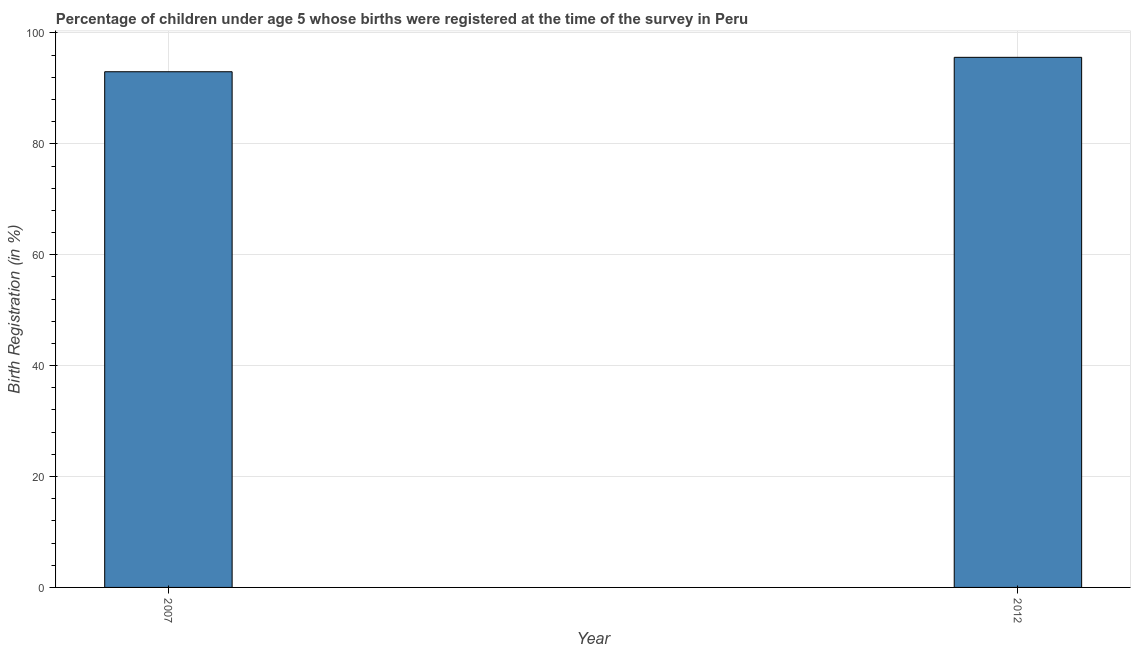What is the title of the graph?
Offer a terse response. Percentage of children under age 5 whose births were registered at the time of the survey in Peru. What is the label or title of the X-axis?
Ensure brevity in your answer.  Year. What is the label or title of the Y-axis?
Your response must be concise. Birth Registration (in %). What is the birth registration in 2012?
Your answer should be very brief. 95.6. Across all years, what is the maximum birth registration?
Provide a short and direct response. 95.6. Across all years, what is the minimum birth registration?
Keep it short and to the point. 93. In which year was the birth registration maximum?
Offer a terse response. 2012. What is the sum of the birth registration?
Your answer should be very brief. 188.6. What is the difference between the birth registration in 2007 and 2012?
Provide a succinct answer. -2.6. What is the average birth registration per year?
Your answer should be very brief. 94.3. What is the median birth registration?
Provide a short and direct response. 94.3. In how many years, is the birth registration greater than 48 %?
Provide a succinct answer. 2. Do a majority of the years between 2007 and 2012 (inclusive) have birth registration greater than 44 %?
Offer a very short reply. Yes. What is the ratio of the birth registration in 2007 to that in 2012?
Offer a terse response. 0.97. Is the birth registration in 2007 less than that in 2012?
Your answer should be compact. Yes. How many bars are there?
Provide a succinct answer. 2. How many years are there in the graph?
Your answer should be very brief. 2. What is the difference between two consecutive major ticks on the Y-axis?
Offer a very short reply. 20. What is the Birth Registration (in %) in 2007?
Keep it short and to the point. 93. What is the Birth Registration (in %) in 2012?
Give a very brief answer. 95.6. 